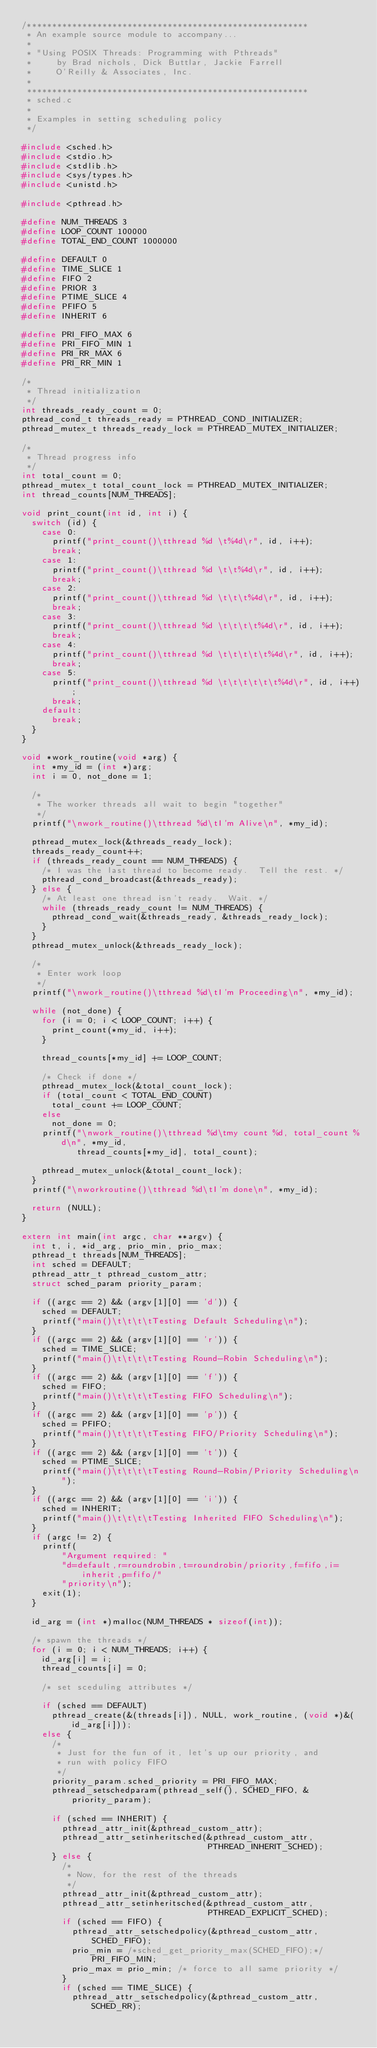Convert code to text. <code><loc_0><loc_0><loc_500><loc_500><_C_>/********************************************************
 * An example source module to accompany...
 *
 * "Using POSIX Threads: Programming with Pthreads"
 *     by Brad nichols, Dick Buttlar, Jackie Farrell
 *     O'Reilly & Associates, Inc.
 *
 ********************************************************
 * sched.c
 *
 * Examples in setting scheduling policy
 */

#include <sched.h>
#include <stdio.h>
#include <stdlib.h>
#include <sys/types.h>
#include <unistd.h>

#include <pthread.h>

#define NUM_THREADS 3
#define LOOP_COUNT 100000
#define TOTAL_END_COUNT 1000000

#define DEFAULT 0
#define TIME_SLICE 1
#define FIFO 2
#define PRIOR 3
#define PTIME_SLICE 4
#define PFIFO 5
#define INHERIT 6

#define PRI_FIFO_MAX 6
#define PRI_FIFO_MIN 1
#define PRI_RR_MAX 6
#define PRI_RR_MIN 1

/*
 * Thread initialization
 */
int threads_ready_count = 0;
pthread_cond_t threads_ready = PTHREAD_COND_INITIALIZER;
pthread_mutex_t threads_ready_lock = PTHREAD_MUTEX_INITIALIZER;

/*
 * Thread progress info
 */
int total_count = 0;
pthread_mutex_t total_count_lock = PTHREAD_MUTEX_INITIALIZER;
int thread_counts[NUM_THREADS];

void print_count(int id, int i) {
  switch (id) {
    case 0:
      printf("print_count()\tthread %d \t%4d\r", id, i++);
      break;
    case 1:
      printf("print_count()\tthread %d \t\t%4d\r", id, i++);
      break;
    case 2:
      printf("print_count()\tthread %d \t\t\t%4d\r", id, i++);
      break;
    case 3:
      printf("print_count()\tthread %d \t\t\t\t%4d\r", id, i++);
      break;
    case 4:
      printf("print_count()\tthread %d \t\t\t\t\t%4d\r", id, i++);
      break;
    case 5:
      printf("print_count()\tthread %d \t\t\t\t\t\t%4d\r", id, i++);
      break;
    default:
      break;
  }
}

void *work_routine(void *arg) {
  int *my_id = (int *)arg;
  int i = 0, not_done = 1;

  /*
   * The worker threads all wait to begin "together"
   */
  printf("\nwork_routine()\tthread %d\tI'm Alive\n", *my_id);

  pthread_mutex_lock(&threads_ready_lock);
  threads_ready_count++;
  if (threads_ready_count == NUM_THREADS) {
    /* I was the last thread to become ready.  Tell the rest. */
    pthread_cond_broadcast(&threads_ready);
  } else {
    /* At least one thread isn't ready.  Wait. */
    while (threads_ready_count != NUM_THREADS) {
      pthread_cond_wait(&threads_ready, &threads_ready_lock);
    }
  }
  pthread_mutex_unlock(&threads_ready_lock);

  /*
   * Enter work loop
   */
  printf("\nwork_routine()\tthread %d\tI'm Proceeding\n", *my_id);

  while (not_done) {
    for (i = 0; i < LOOP_COUNT; i++) {
      print_count(*my_id, i++);
    }

    thread_counts[*my_id] += LOOP_COUNT;

    /* Check if done */
    pthread_mutex_lock(&total_count_lock);
    if (total_count < TOTAL_END_COUNT)
      total_count += LOOP_COUNT;
    else
      not_done = 0;
    printf("\nwork_routine()\tthread %d\tmy count %d, total_count %d\n", *my_id,
           thread_counts[*my_id], total_count);

    pthread_mutex_unlock(&total_count_lock);
  }
  printf("\nworkroutine()\tthread %d\tI'm done\n", *my_id);

  return (NULL);
}

extern int main(int argc, char **argv) {
  int t, i, *id_arg, prio_min, prio_max;
  pthread_t threads[NUM_THREADS];
  int sched = DEFAULT;
  pthread_attr_t pthread_custom_attr;
  struct sched_param priority_param;

  if ((argc == 2) && (argv[1][0] == 'd')) {
    sched = DEFAULT;
    printf("main()\t\t\t\tTesting Default Scheduling\n");
  }
  if ((argc == 2) && (argv[1][0] == 'r')) {
    sched = TIME_SLICE;
    printf("main()\t\t\t\tTesting Round-Robin Scheduling\n");
  }
  if ((argc == 2) && (argv[1][0] == 'f')) {
    sched = FIFO;
    printf("main()\t\t\t\tTesting FIFO Scheduling\n");
  }
  if ((argc == 2) && (argv[1][0] == 'p')) {
    sched = PFIFO;
    printf("main()\t\t\t\tTesting FIFO/Priority Scheduling\n");
  }
  if ((argc == 2) && (argv[1][0] == 't')) {
    sched = PTIME_SLICE;
    printf("main()\t\t\t\tTesting Round-Robin/Priority Scheduling\n");
  }
  if ((argc == 2) && (argv[1][0] == 'i')) {
    sched = INHERIT;
    printf("main()\t\t\t\tTesting Inherited FIFO Scheduling\n");
  }
  if (argc != 2) {
    printf(
        "Argument required: "
        "d=default,r=roundrobin,t=roundrobin/priority,f=fifo,i=inherit,p=fifo/"
        "priority\n");
    exit(1);
  }

  id_arg = (int *)malloc(NUM_THREADS * sizeof(int));

  /* spawn the threads */
  for (i = 0; i < NUM_THREADS; i++) {
    id_arg[i] = i;
    thread_counts[i] = 0;

    /* set sceduling attributes */

    if (sched == DEFAULT)
      pthread_create(&(threads[i]), NULL, work_routine, (void *)&(id_arg[i]));
    else {
      /*
       * Just for the fun of it, let's up our priority, and
       * run with policy FIFO
       */
      priority_param.sched_priority = PRI_FIFO_MAX;
      pthread_setschedparam(pthread_self(), SCHED_FIFO, &priority_param);

      if (sched == INHERIT) {
        pthread_attr_init(&pthread_custom_attr);
        pthread_attr_setinheritsched(&pthread_custom_attr,
                                     PTHREAD_INHERIT_SCHED);
      } else {
        /*
         * Now, for the rest of the threads
         */
        pthread_attr_init(&pthread_custom_attr);
        pthread_attr_setinheritsched(&pthread_custom_attr,
                                     PTHREAD_EXPLICIT_SCHED);
        if (sched == FIFO) {
          pthread_attr_setschedpolicy(&pthread_custom_attr, SCHED_FIFO);
          prio_min = /*sched_get_priority_max(SCHED_FIFO);*/ PRI_FIFO_MIN;
          prio_max = prio_min; /* force to all same priority */
        }
        if (sched == TIME_SLICE) {
          pthread_attr_setschedpolicy(&pthread_custom_attr, SCHED_RR);</code> 